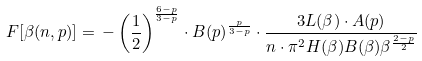<formula> <loc_0><loc_0><loc_500><loc_500>F [ \beta ( n , p ) ] = \, - \left ( \frac { 1 } { 2 } \right ) ^ { \frac { 6 - p } { 3 - p } } \cdot B ( p ) ^ { \frac { p } { 3 - p } } \cdot \frac { 3 L ( \beta ) \cdot A ( p ) } { n \cdot \pi ^ { 2 } H ( \beta ) B ( \beta ) \beta ^ { \frac { 2 - p } { 2 } } }</formula> 